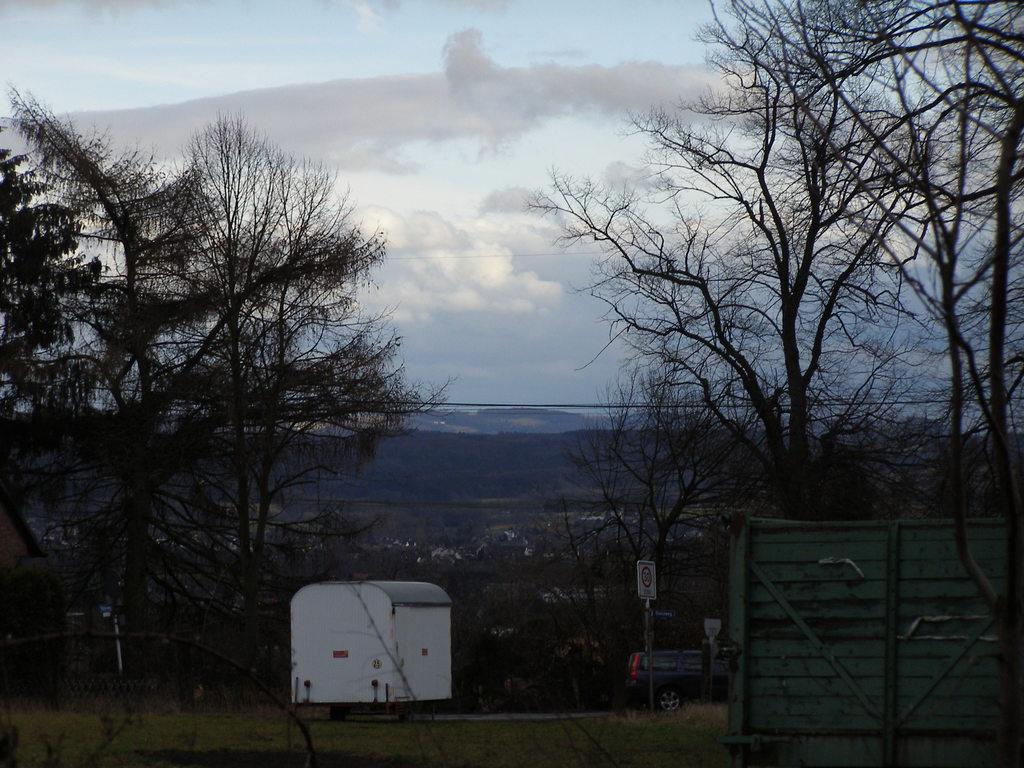What type of vegetation is on the left side of the image? There are trees on the left side of the image. What type of vegetation is on the right side of the image? There are trees on the right side of the image. What type of vehicle is in the image? There is a car in the image. What can be seen in the background of the image? There are clouds and the sky visible in the background of the image. What type of crime is being committed in the image? There is no crime being committed in the image; it features trees, a car, and a sky background. What card game is being played in the image? There is no card game being played in the image; it features trees, a car, and a sky background. 